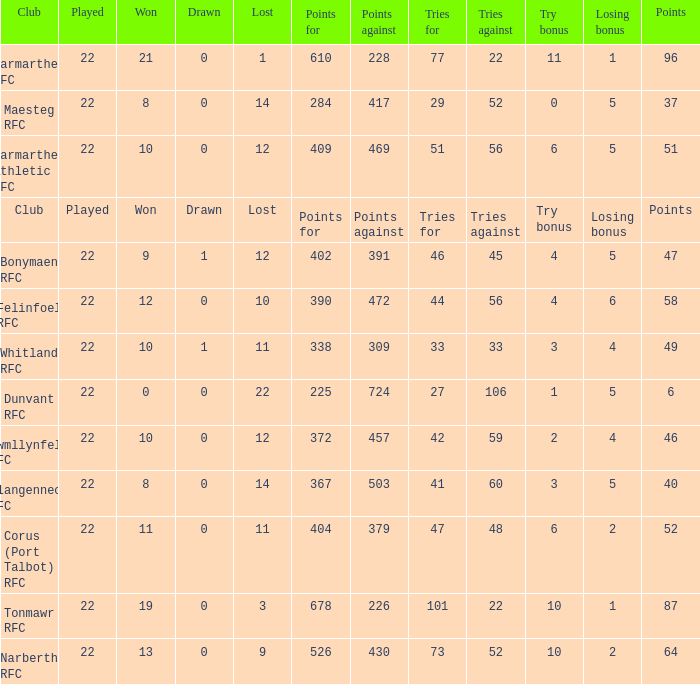Name the try bonus of points against at 430 10.0. 